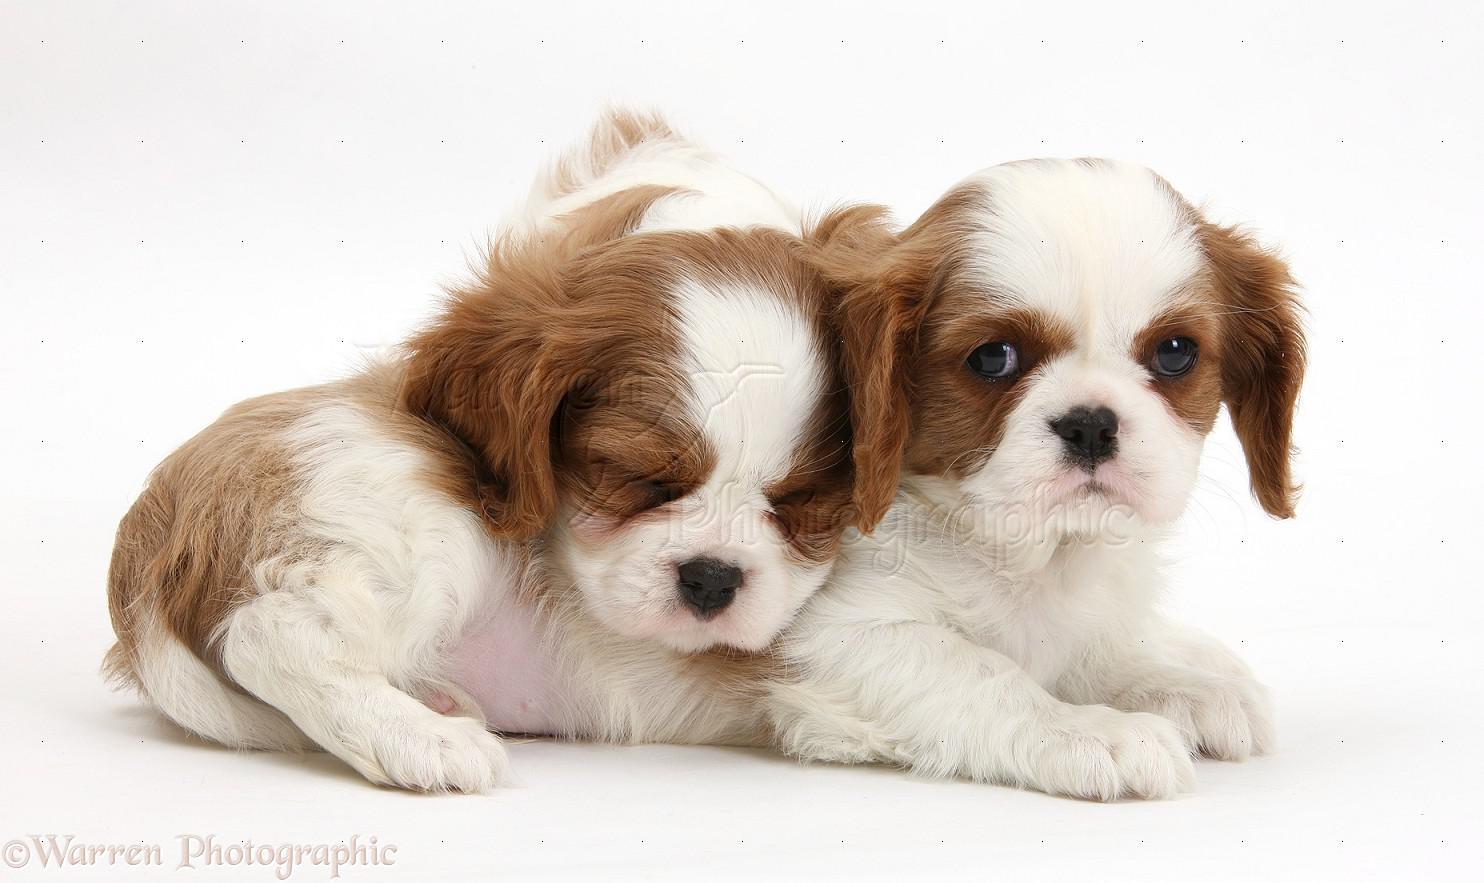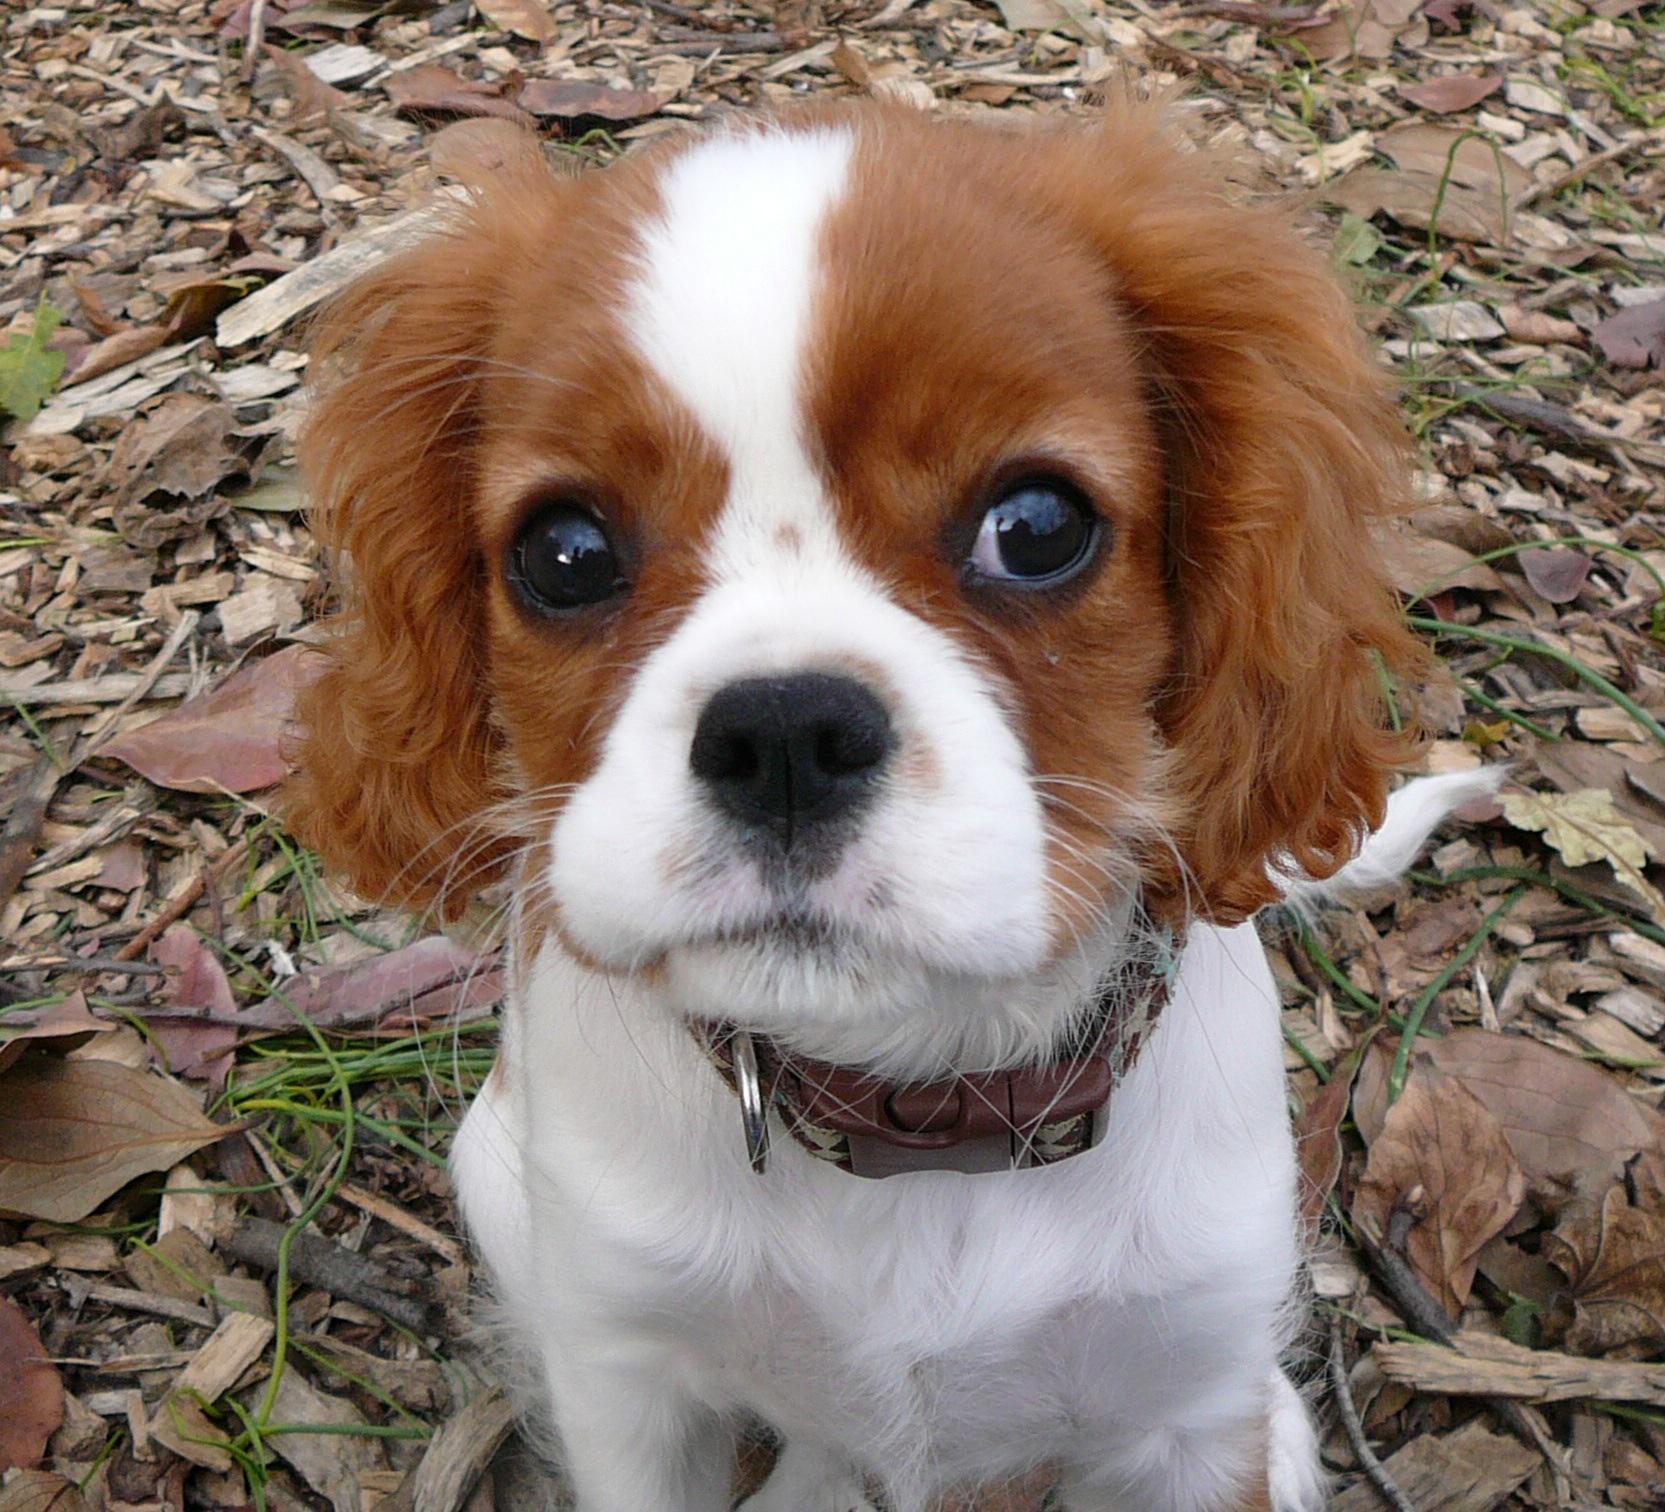The first image is the image on the left, the second image is the image on the right. For the images shown, is this caption "One of the images contains exactly two puppies." true? Answer yes or no. Yes. 